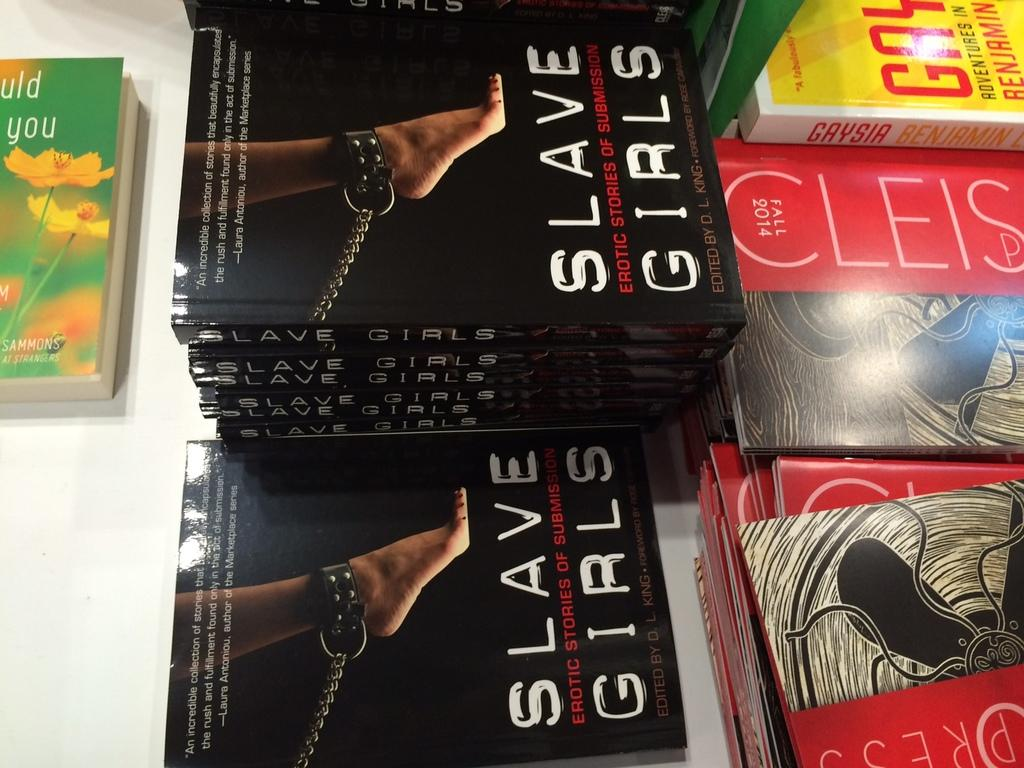<image>
Offer a succinct explanation of the picture presented. A book called Slave Girls is on display among other books 